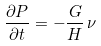<formula> <loc_0><loc_0><loc_500><loc_500>\frac { \partial P } { \partial t } = - \frac { G } { H } \, \nu</formula> 